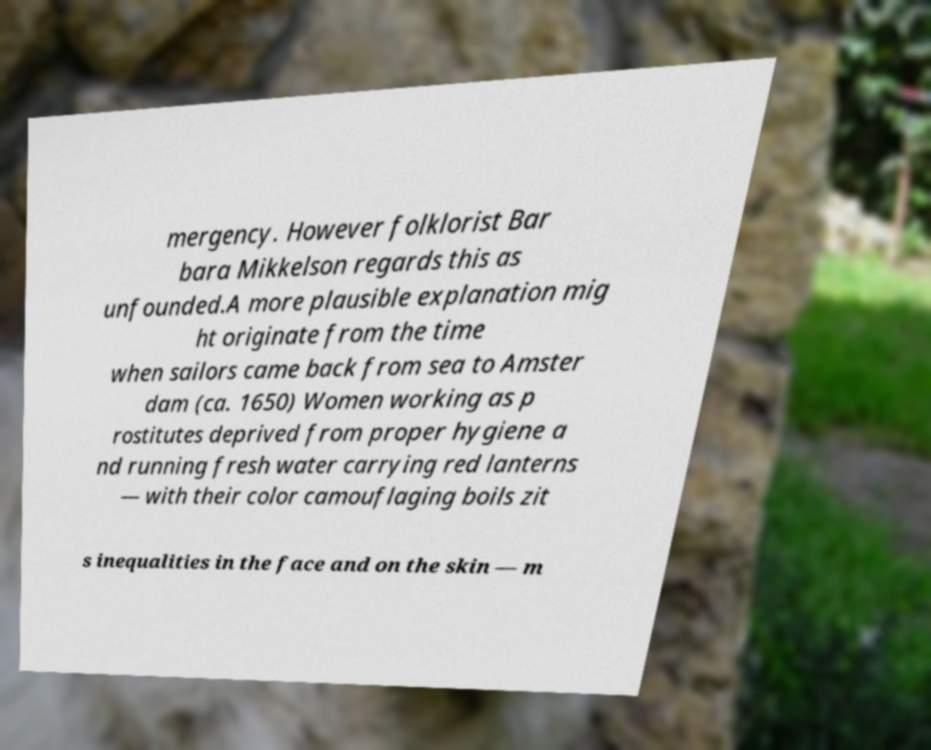Please read and relay the text visible in this image. What does it say? mergency. However folklorist Bar bara Mikkelson regards this as unfounded.A more plausible explanation mig ht originate from the time when sailors came back from sea to Amster dam (ca. 1650) Women working as p rostitutes deprived from proper hygiene a nd running fresh water carrying red lanterns — with their color camouflaging boils zit s inequalities in the face and on the skin — m 